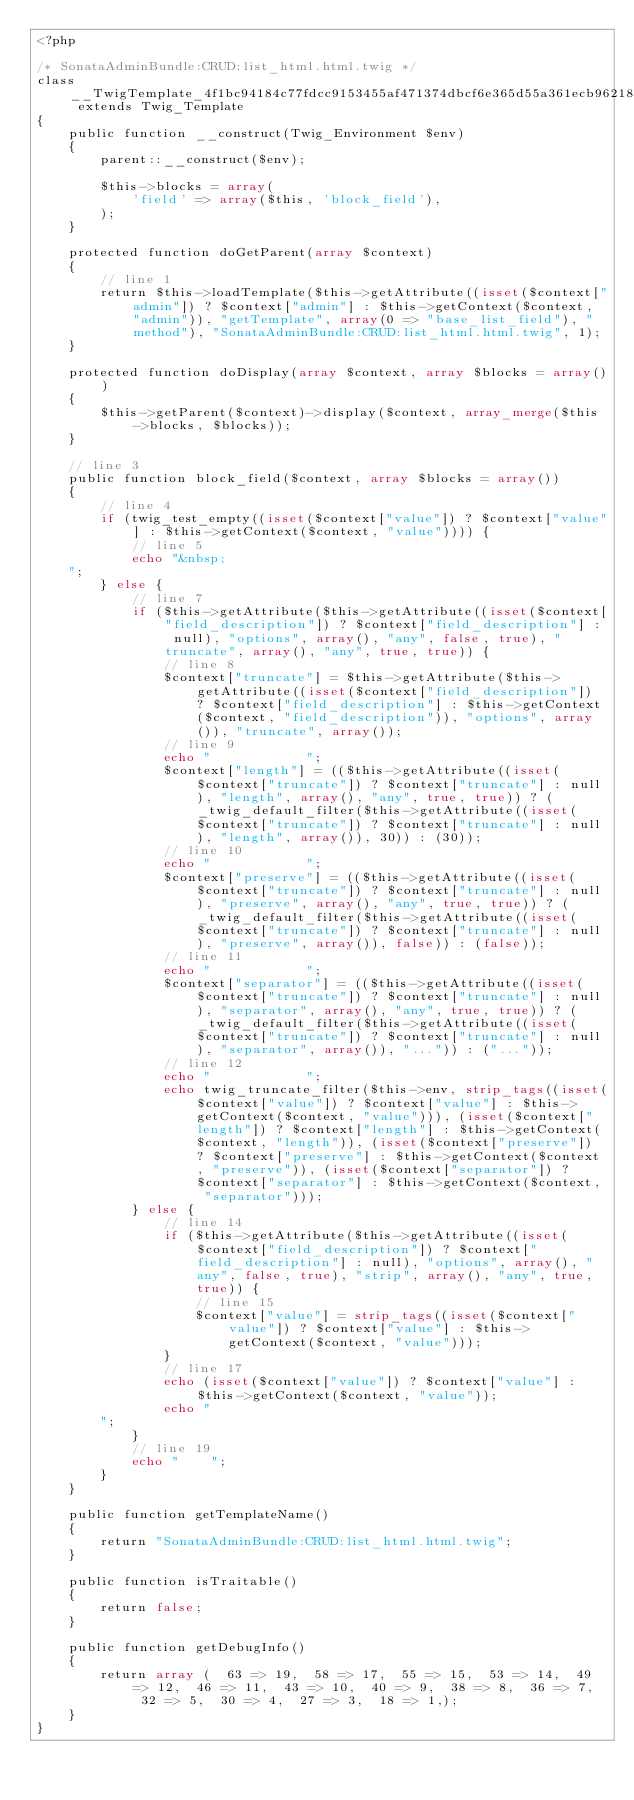<code> <loc_0><loc_0><loc_500><loc_500><_PHP_><?php

/* SonataAdminBundle:CRUD:list_html.html.twig */
class __TwigTemplate_4f1bc94184c77fdcc9153455af471374dbcf6e365d55a361ecb962189d7a3df6 extends Twig_Template
{
    public function __construct(Twig_Environment $env)
    {
        parent::__construct($env);

        $this->blocks = array(
            'field' => array($this, 'block_field'),
        );
    }

    protected function doGetParent(array $context)
    {
        // line 1
        return $this->loadTemplate($this->getAttribute((isset($context["admin"]) ? $context["admin"] : $this->getContext($context, "admin")), "getTemplate", array(0 => "base_list_field"), "method"), "SonataAdminBundle:CRUD:list_html.html.twig", 1);
    }

    protected function doDisplay(array $context, array $blocks = array())
    {
        $this->getParent($context)->display($context, array_merge($this->blocks, $blocks));
    }

    // line 3
    public function block_field($context, array $blocks = array())
    {
        // line 4
        if (twig_test_empty((isset($context["value"]) ? $context["value"] : $this->getContext($context, "value")))) {
            // line 5
            echo "&nbsp;
    ";
        } else {
            // line 7
            if ($this->getAttribute($this->getAttribute((isset($context["field_description"]) ? $context["field_description"] : null), "options", array(), "any", false, true), "truncate", array(), "any", true, true)) {
                // line 8
                $context["truncate"] = $this->getAttribute($this->getAttribute((isset($context["field_description"]) ? $context["field_description"] : $this->getContext($context, "field_description")), "options", array()), "truncate", array());
                // line 9
                echo "            ";
                $context["length"] = (($this->getAttribute((isset($context["truncate"]) ? $context["truncate"] : null), "length", array(), "any", true, true)) ? (_twig_default_filter($this->getAttribute((isset($context["truncate"]) ? $context["truncate"] : null), "length", array()), 30)) : (30));
                // line 10
                echo "            ";
                $context["preserve"] = (($this->getAttribute((isset($context["truncate"]) ? $context["truncate"] : null), "preserve", array(), "any", true, true)) ? (_twig_default_filter($this->getAttribute((isset($context["truncate"]) ? $context["truncate"] : null), "preserve", array()), false)) : (false));
                // line 11
                echo "            ";
                $context["separator"] = (($this->getAttribute((isset($context["truncate"]) ? $context["truncate"] : null), "separator", array(), "any", true, true)) ? (_twig_default_filter($this->getAttribute((isset($context["truncate"]) ? $context["truncate"] : null), "separator", array()), "...")) : ("..."));
                // line 12
                echo "            ";
                echo twig_truncate_filter($this->env, strip_tags((isset($context["value"]) ? $context["value"] : $this->getContext($context, "value"))), (isset($context["length"]) ? $context["length"] : $this->getContext($context, "length")), (isset($context["preserve"]) ? $context["preserve"] : $this->getContext($context, "preserve")), (isset($context["separator"]) ? $context["separator"] : $this->getContext($context, "separator")));
            } else {
                // line 14
                if ($this->getAttribute($this->getAttribute((isset($context["field_description"]) ? $context["field_description"] : null), "options", array(), "any", false, true), "strip", array(), "any", true, true)) {
                    // line 15
                    $context["value"] = strip_tags((isset($context["value"]) ? $context["value"] : $this->getContext($context, "value")));
                }
                // line 17
                echo (isset($context["value"]) ? $context["value"] : $this->getContext($context, "value"));
                echo "
        ";
            }
            // line 19
            echo "    ";
        }
    }

    public function getTemplateName()
    {
        return "SonataAdminBundle:CRUD:list_html.html.twig";
    }

    public function isTraitable()
    {
        return false;
    }

    public function getDebugInfo()
    {
        return array (  63 => 19,  58 => 17,  55 => 15,  53 => 14,  49 => 12,  46 => 11,  43 => 10,  40 => 9,  38 => 8,  36 => 7,  32 => 5,  30 => 4,  27 => 3,  18 => 1,);
    }
}
</code> 